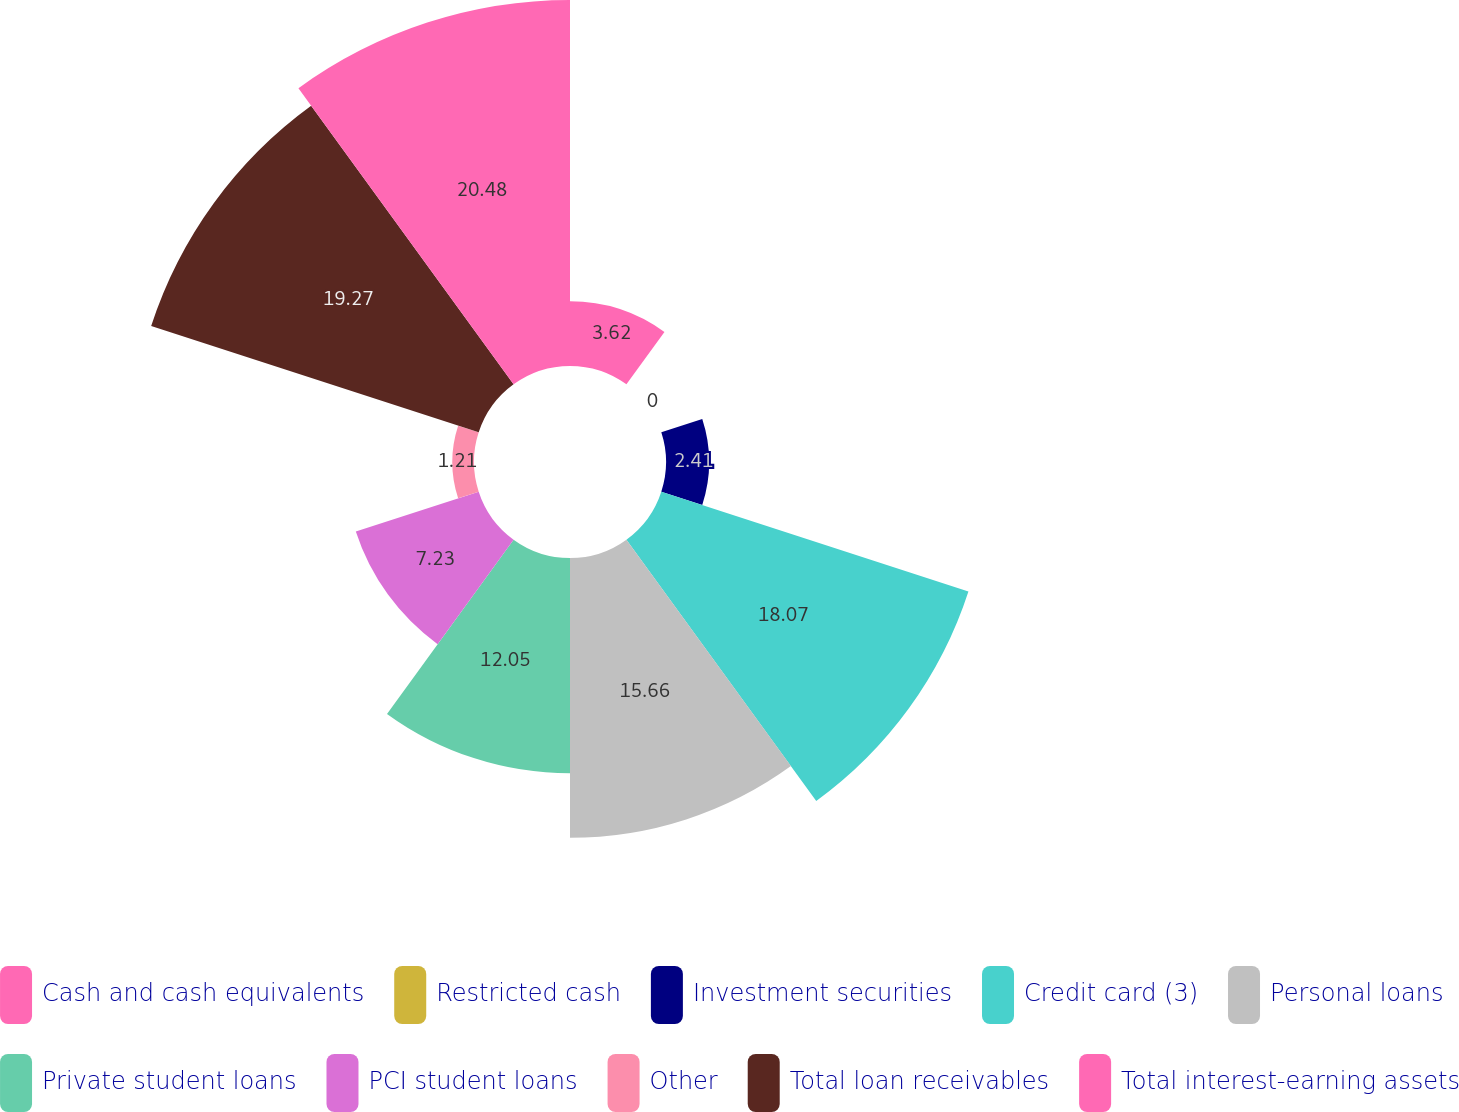Convert chart. <chart><loc_0><loc_0><loc_500><loc_500><pie_chart><fcel>Cash and cash equivalents<fcel>Restricted cash<fcel>Investment securities<fcel>Credit card (3)<fcel>Personal loans<fcel>Private student loans<fcel>PCI student loans<fcel>Other<fcel>Total loan receivables<fcel>Total interest-earning assets<nl><fcel>3.62%<fcel>0.0%<fcel>2.41%<fcel>18.07%<fcel>15.66%<fcel>12.05%<fcel>7.23%<fcel>1.21%<fcel>19.27%<fcel>20.48%<nl></chart> 